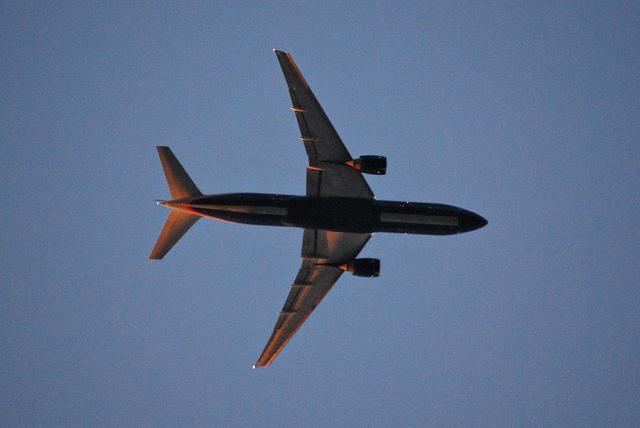What geometrical shape is seen on the black portion of the plane?
Write a very short answer. Triangle. Which way is the plane angled?
Short answer required. Right. Is this the top or bottom of the plane?
Concise answer only. Bottom. Is this a cloudy day?
Answer briefly. No. What color is the sky?
Concise answer only. Blue. 